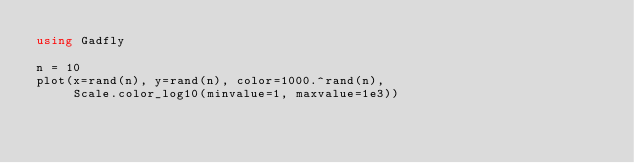Convert code to text. <code><loc_0><loc_0><loc_500><loc_500><_Julia_>using Gadfly

n = 10
plot(x=rand(n), y=rand(n), color=1000.^rand(n),
     Scale.color_log10(minvalue=1, maxvalue=1e3))
</code> 